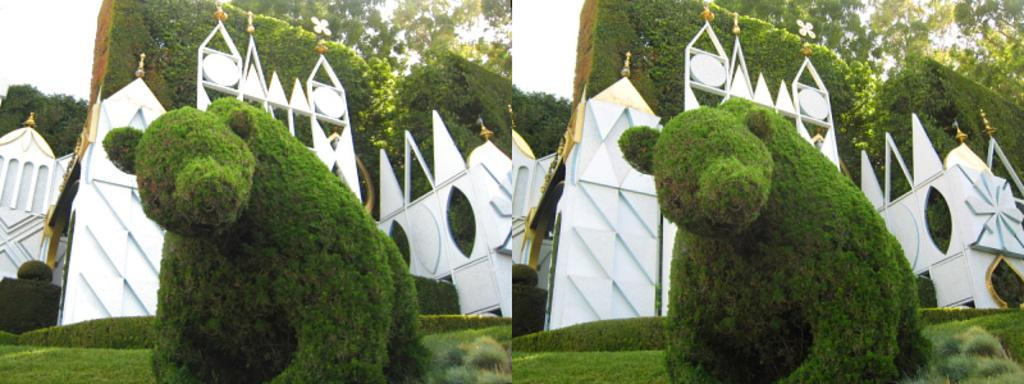What type of artwork is depicted in the image? The image is a collage. What kind of tree can be seen in the image? There is an animal-shaped tree in the image. What type of vegetation is present in the image? There is grass in the image. What architectural feature is present in the image? There are arches in the image. What can be seen in the background of the image? The sky is visible in the background of the image. Where can the market be found in the image? There is no market present in the image. What type of shoes can be seen on the animal-shaped tree? There are no shoes present in the image, and the tree is not a real animal. 